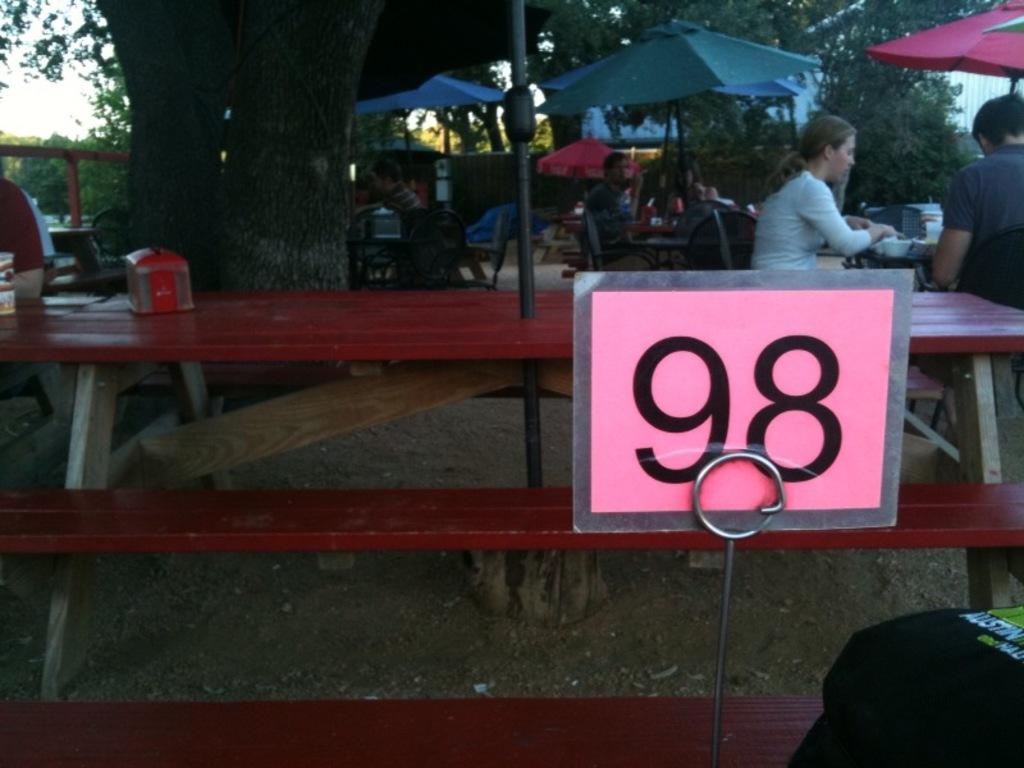How many people are in the image? There is a group of people in the image. What are the people doing in the image? The people are sitting on chairs. What is on the table in the image? There is a bowl on a table. What object provides shade in the image? There is an umbrella in the image. What object can be used for writing or displaying information? There is a board in the image. What type of vegetation is visible in the background? There is a tree visible in the background. What part of the natural environment is visible in the background? The sky is visible in the background. What type of bird can be seen flying near the tree in the image? There is no bird visible in the image; only the tree and sky are present in the background. 